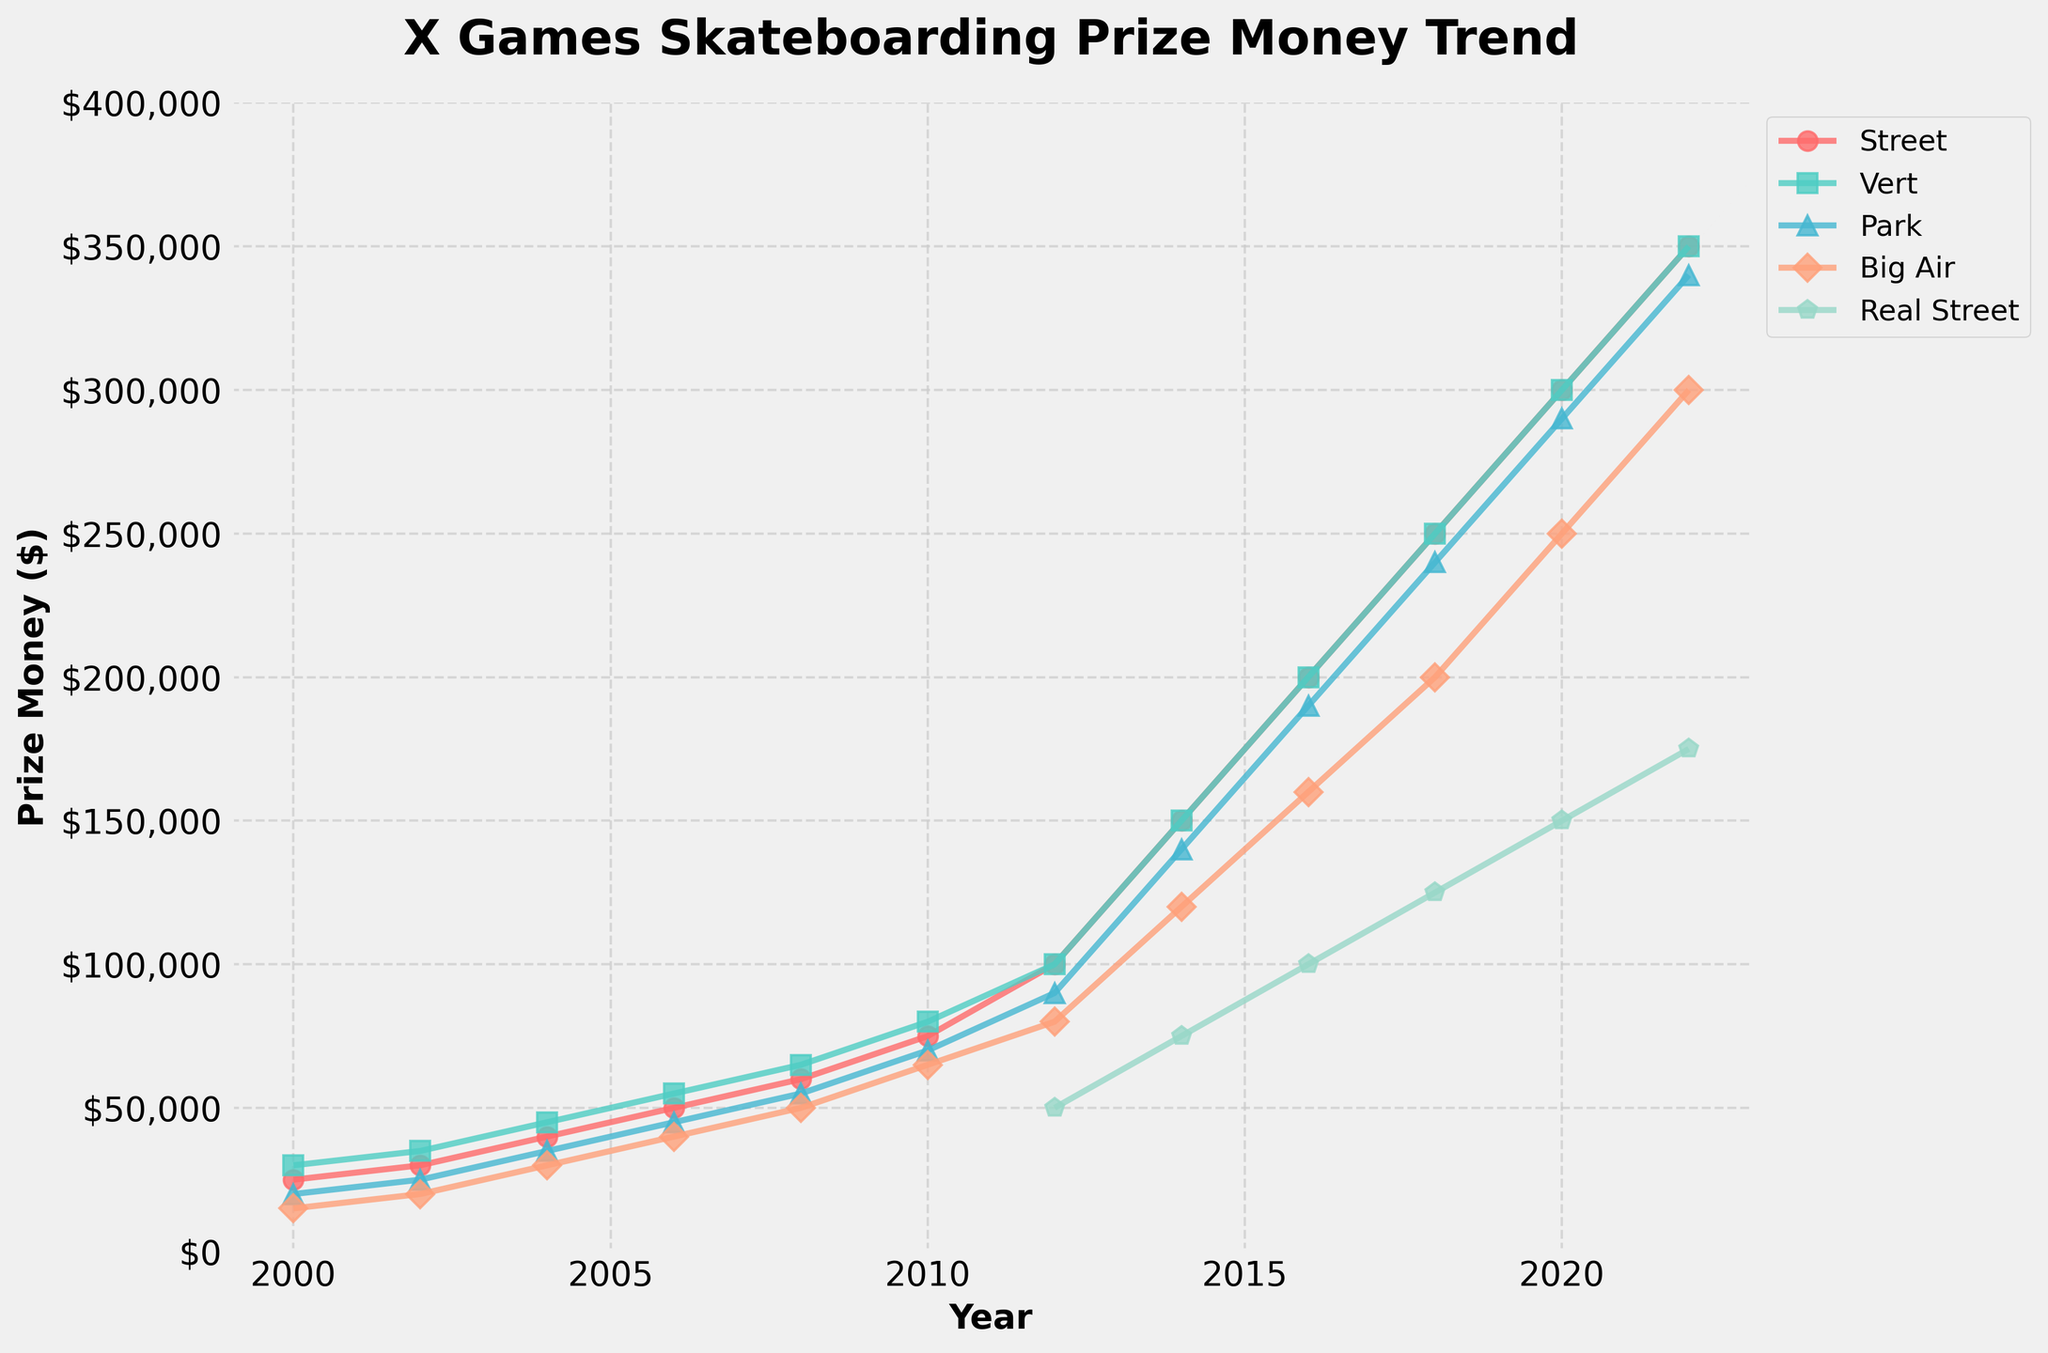Which event had the highest prize money in 2022? To find the event with the highest prize money in 2022, observe the lines in the figure for the year 2022 and compare their heights. The "Street" and "Vert" categories both reach the highest point on the y-axis.
Answer: Street and Vert How did the prize money for the Big Air event change from 2000 to 2022? Look at the starting point of the Big Air line in 2000 and its endpoint in 2022. In 2000, the prize money for Big Air was $15,000, and in 2022, it increased to $300,000. Calculate the difference by subtracting $15,000 from $300,000.
Answer: Increased by $285,000 Which year saw the introduction of prize money for the Real Street event? Look for the year where the Real Street line (marked with a pentagon marker) first appears on the graph. This occurs in 2012.
Answer: 2012 In 2018, how much more was the prize money for the Park event compared to the Real Street event? Observe the prize money values for both Park and Real Street in 2018. Park had $240,000, and Real Street had $125,000. Subtract $125,000 from $240,000 to get the difference.
Answer: $115,000 By how much did the prize money for the Vert event increase between 2008 and 2010? Look at the Vert prize money in 2008 ($65,000) and in 2010 ($80,000). Subtract $65,000 from $80,000.
Answer: $15,000 Which event had the smallest increase in prize money between 2010 and 2012? Calculate the increase for each event between 2010 and 2012: Street ($100,000 - $75,000 = $25,000), Vert ($100,000 - $80,000 = $20,000), Park ($90,000 - $70,000 = $20,000), Big Air ($80,000 - $65,000 = $15,000). Real Street data starts in 2012 so it's not considered. The Big Air event had the smallest increase.
Answer: Big Air What is the prize money gap between the Park and Vert events in 2014? Look at the prize money values for Park ($140,000) and Vert ($150,000) in 2014. Subtract $140,000 from $150,000 to find the difference.
Answer: $10,000 Between 2004 and 2006, which event saw the largest percentage increase in prize money? Calculate the percentage increase for each event from 2004 to 2006: Street: (($50,000 - $40,000) / $40,000) * 100 = 25%, Vert: (($55,000 - $45,000) / $45,000) * 100 = 22.2%, Park: (($45,000 - $35,000) / $35,000) * 100 = 28.6%, Big Air: (($40,000 - $30,000) / $30,000) * 100 = 33.3%. The Big Air event had the largest percentage increase.
Answer: Big Air 